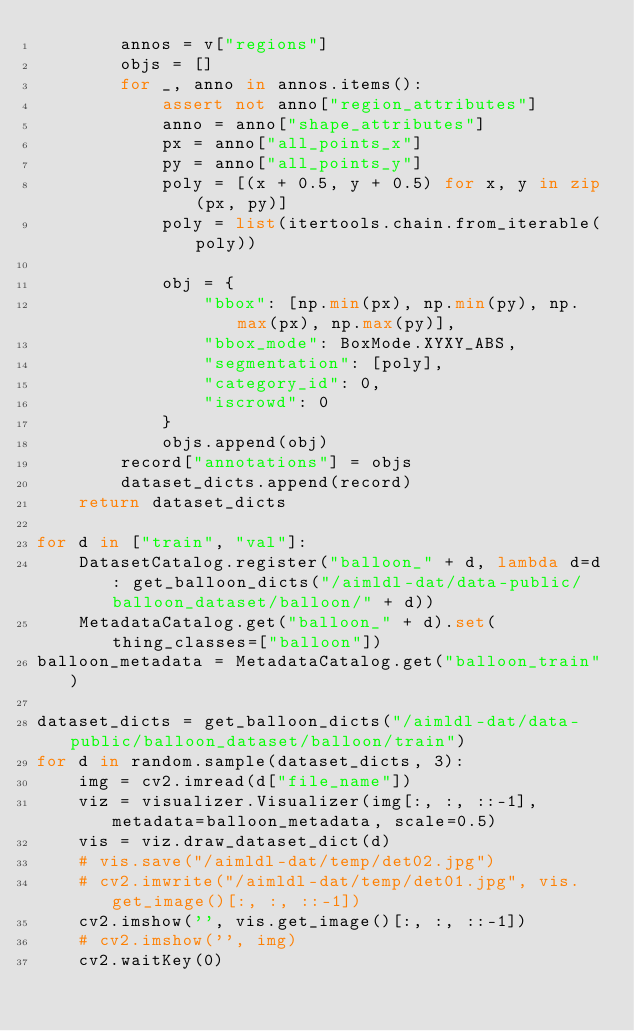<code> <loc_0><loc_0><loc_500><loc_500><_Python_>        annos = v["regions"]
        objs = []
        for _, anno in annos.items():
            assert not anno["region_attributes"]
            anno = anno["shape_attributes"]
            px = anno["all_points_x"]
            py = anno["all_points_y"]
            poly = [(x + 0.5, y + 0.5) for x, y in zip(px, py)]
            poly = list(itertools.chain.from_iterable(poly))

            obj = {
                "bbox": [np.min(px), np.min(py), np.max(px), np.max(py)],
                "bbox_mode": BoxMode.XYXY_ABS,
                "segmentation": [poly],
                "category_id": 0,
                "iscrowd": 0
            }
            objs.append(obj)
        record["annotations"] = objs
        dataset_dicts.append(record)
    return dataset_dicts

for d in ["train", "val"]:
    DatasetCatalog.register("balloon_" + d, lambda d=d: get_balloon_dicts("/aimldl-dat/data-public/balloon_dataset/balloon/" + d))
    MetadataCatalog.get("balloon_" + d).set(thing_classes=["balloon"])
balloon_metadata = MetadataCatalog.get("balloon_train")

dataset_dicts = get_balloon_dicts("/aimldl-dat/data-public/balloon_dataset/balloon/train")
for d in random.sample(dataset_dicts, 3):
    img = cv2.imread(d["file_name"])
    viz = visualizer.Visualizer(img[:, :, ::-1], metadata=balloon_metadata, scale=0.5)
    vis = viz.draw_dataset_dict(d)
    # vis.save("/aimldl-dat/temp/det02.jpg")
    # cv2.imwrite("/aimldl-dat/temp/det01.jpg", vis.get_image()[:, :, ::-1])
    cv2.imshow('', vis.get_image()[:, :, ::-1])
    # cv2.imshow('', img)
    cv2.waitKey(0)
</code> 